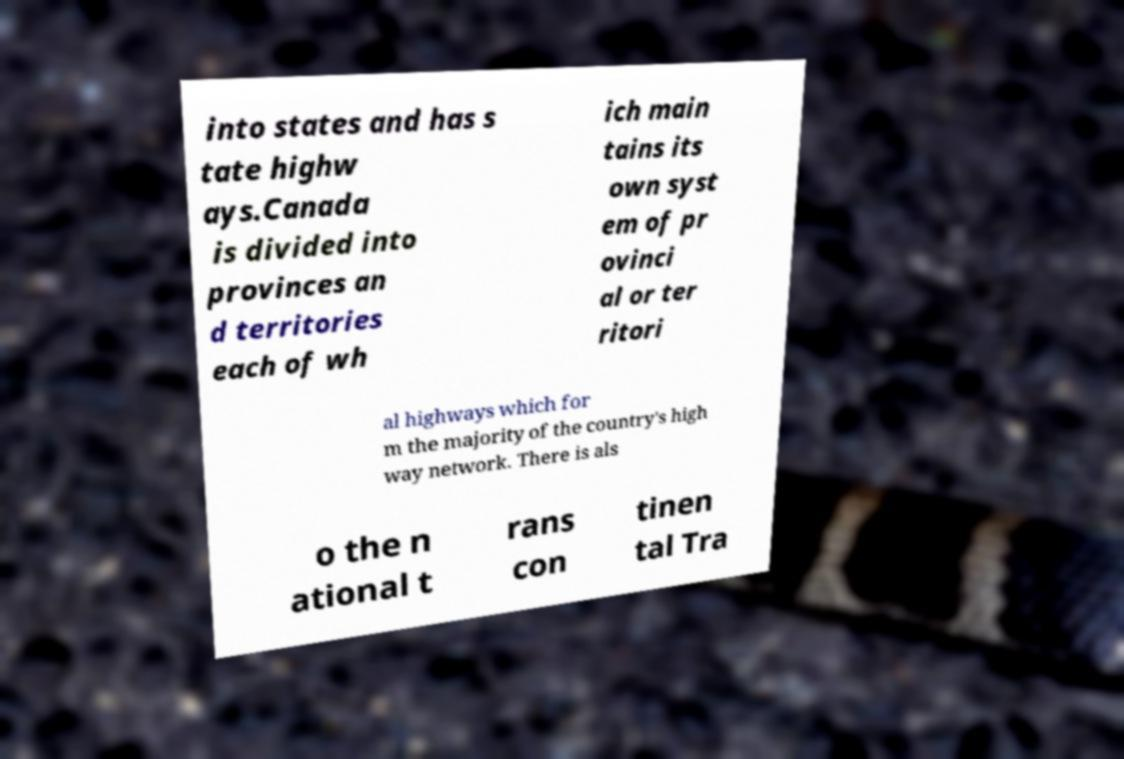Can you accurately transcribe the text from the provided image for me? into states and has s tate highw ays.Canada is divided into provinces an d territories each of wh ich main tains its own syst em of pr ovinci al or ter ritori al highways which for m the majority of the country's high way network. There is als o the n ational t rans con tinen tal Tra 